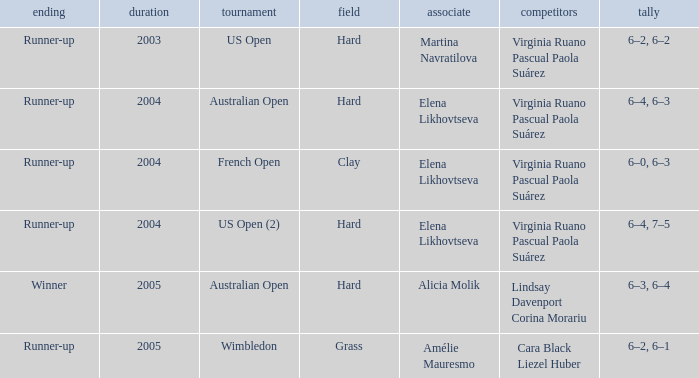When Australian open is the championship what is the lowest year? 2004.0. 